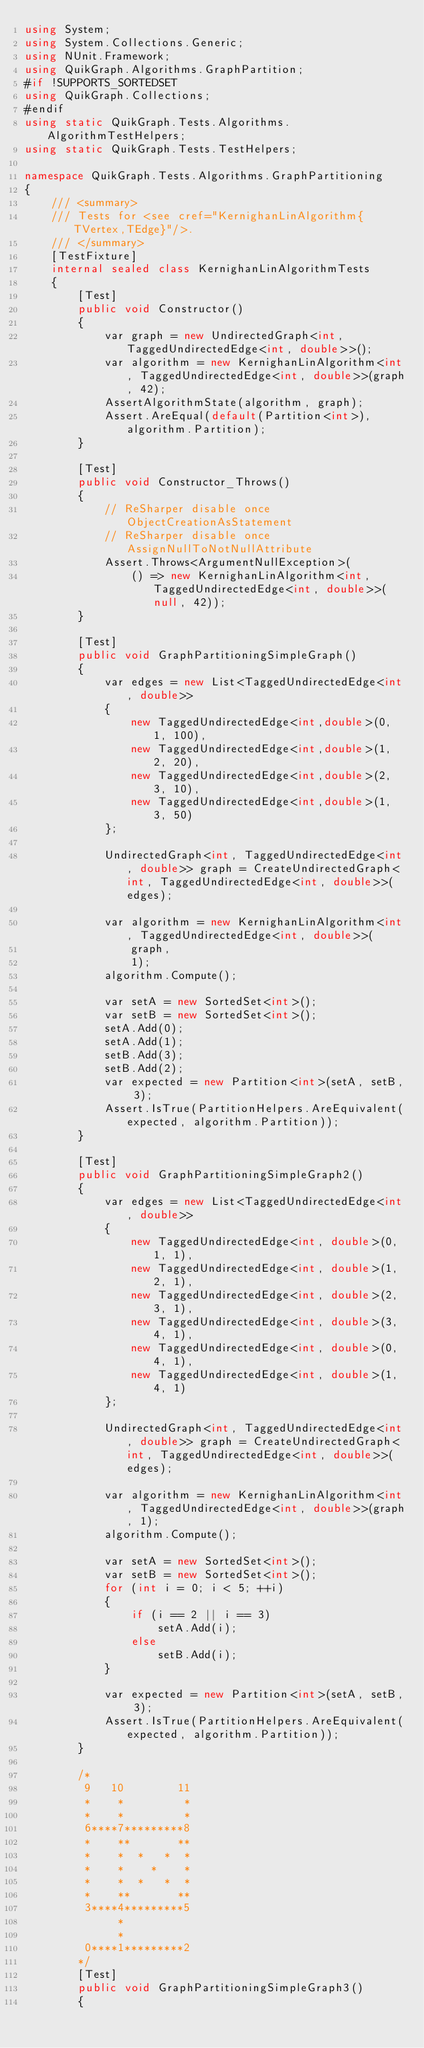Convert code to text. <code><loc_0><loc_0><loc_500><loc_500><_C#_>using System;
using System.Collections.Generic;
using NUnit.Framework;
using QuikGraph.Algorithms.GraphPartition;
#if !SUPPORTS_SORTEDSET
using QuikGraph.Collections;
#endif
using static QuikGraph.Tests.Algorithms.AlgorithmTestHelpers;
using static QuikGraph.Tests.TestHelpers;

namespace QuikGraph.Tests.Algorithms.GraphPartitioning
{
    /// <summary>
    /// Tests for <see cref="KernighanLinAlgorithm{TVertex,TEdge}"/>.
    /// </summary>
    [TestFixture]
    internal sealed class KernighanLinAlgorithmTests
    {
        [Test]
        public void Constructor()
        {
            var graph = new UndirectedGraph<int, TaggedUndirectedEdge<int, double>>();
            var algorithm = new KernighanLinAlgorithm<int, TaggedUndirectedEdge<int, double>>(graph, 42);
            AssertAlgorithmState(algorithm, graph);
            Assert.AreEqual(default(Partition<int>), algorithm.Partition);
        }

        [Test]
        public void Constructor_Throws()
        {
            // ReSharper disable once ObjectCreationAsStatement
            // ReSharper disable once AssignNullToNotNullAttribute
            Assert.Throws<ArgumentNullException>(
                () => new KernighanLinAlgorithm<int, TaggedUndirectedEdge<int, double>>(null, 42));
        }

        [Test]
        public void GraphPartitioningSimpleGraph()
        {
            var edges = new List<TaggedUndirectedEdge<int, double>>
            {
                new TaggedUndirectedEdge<int,double>(0, 1, 100),
                new TaggedUndirectedEdge<int,double>(1, 2, 20),
                new TaggedUndirectedEdge<int,double>(2, 3, 10),
                new TaggedUndirectedEdge<int,double>(1, 3, 50)
            };

            UndirectedGraph<int, TaggedUndirectedEdge<int, double>> graph = CreateUndirectedGraph<int, TaggedUndirectedEdge<int, double>>(edges);

            var algorithm = new KernighanLinAlgorithm<int, TaggedUndirectedEdge<int, double>>(
                graph,
                1);
            algorithm.Compute();

            var setA = new SortedSet<int>();
            var setB = new SortedSet<int>();
            setA.Add(0);
            setA.Add(1);
            setB.Add(3);
            setB.Add(2);
            var expected = new Partition<int>(setA, setB, 3);
            Assert.IsTrue(PartitionHelpers.AreEquivalent(expected, algorithm.Partition));
        }

        [Test]
        public void GraphPartitioningSimpleGraph2()
        {
            var edges = new List<TaggedUndirectedEdge<int, double>>
            {
                new TaggedUndirectedEdge<int, double>(0, 1, 1),
                new TaggedUndirectedEdge<int, double>(1, 2, 1),
                new TaggedUndirectedEdge<int, double>(2, 3, 1),
                new TaggedUndirectedEdge<int, double>(3, 4, 1),
                new TaggedUndirectedEdge<int, double>(0, 4, 1),
                new TaggedUndirectedEdge<int, double>(1, 4, 1)
            };

            UndirectedGraph<int, TaggedUndirectedEdge<int, double>> graph = CreateUndirectedGraph<int, TaggedUndirectedEdge<int, double>>(edges);

            var algorithm = new KernighanLinAlgorithm<int, TaggedUndirectedEdge<int, double>>(graph, 1);
            algorithm.Compute();

            var setA = new SortedSet<int>();
            var setB = new SortedSet<int>();
            for (int i = 0; i < 5; ++i)
            {
                if (i == 2 || i == 3)
                    setA.Add(i);
                else
                    setB.Add(i);
            }

            var expected = new Partition<int>(setA, setB, 3);
            Assert.IsTrue(PartitionHelpers.AreEquivalent(expected, algorithm.Partition));
        }

        /*
         9   10        11
         *    *         *
         *    *         *
         6****7*********8
         *    **       **
         *    *  *   *  *  
         *    *    *    *
         *    *  *   *  *
         *    **       **
         3****4*********5
              *         
              *         
         0****1*********2
        */
        [Test]
        public void GraphPartitioningSimpleGraph3()
        {</code> 